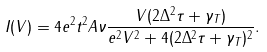<formula> <loc_0><loc_0><loc_500><loc_500>I ( V ) = 4 e ^ { 2 } t ^ { 2 } A \nu \frac { V ( 2 \Delta ^ { 2 } \tau + \gamma _ { T } ) } { e ^ { 2 } V ^ { 2 } + 4 ( 2 \Delta ^ { 2 } \tau + \gamma _ { T } ) ^ { 2 } } .</formula> 